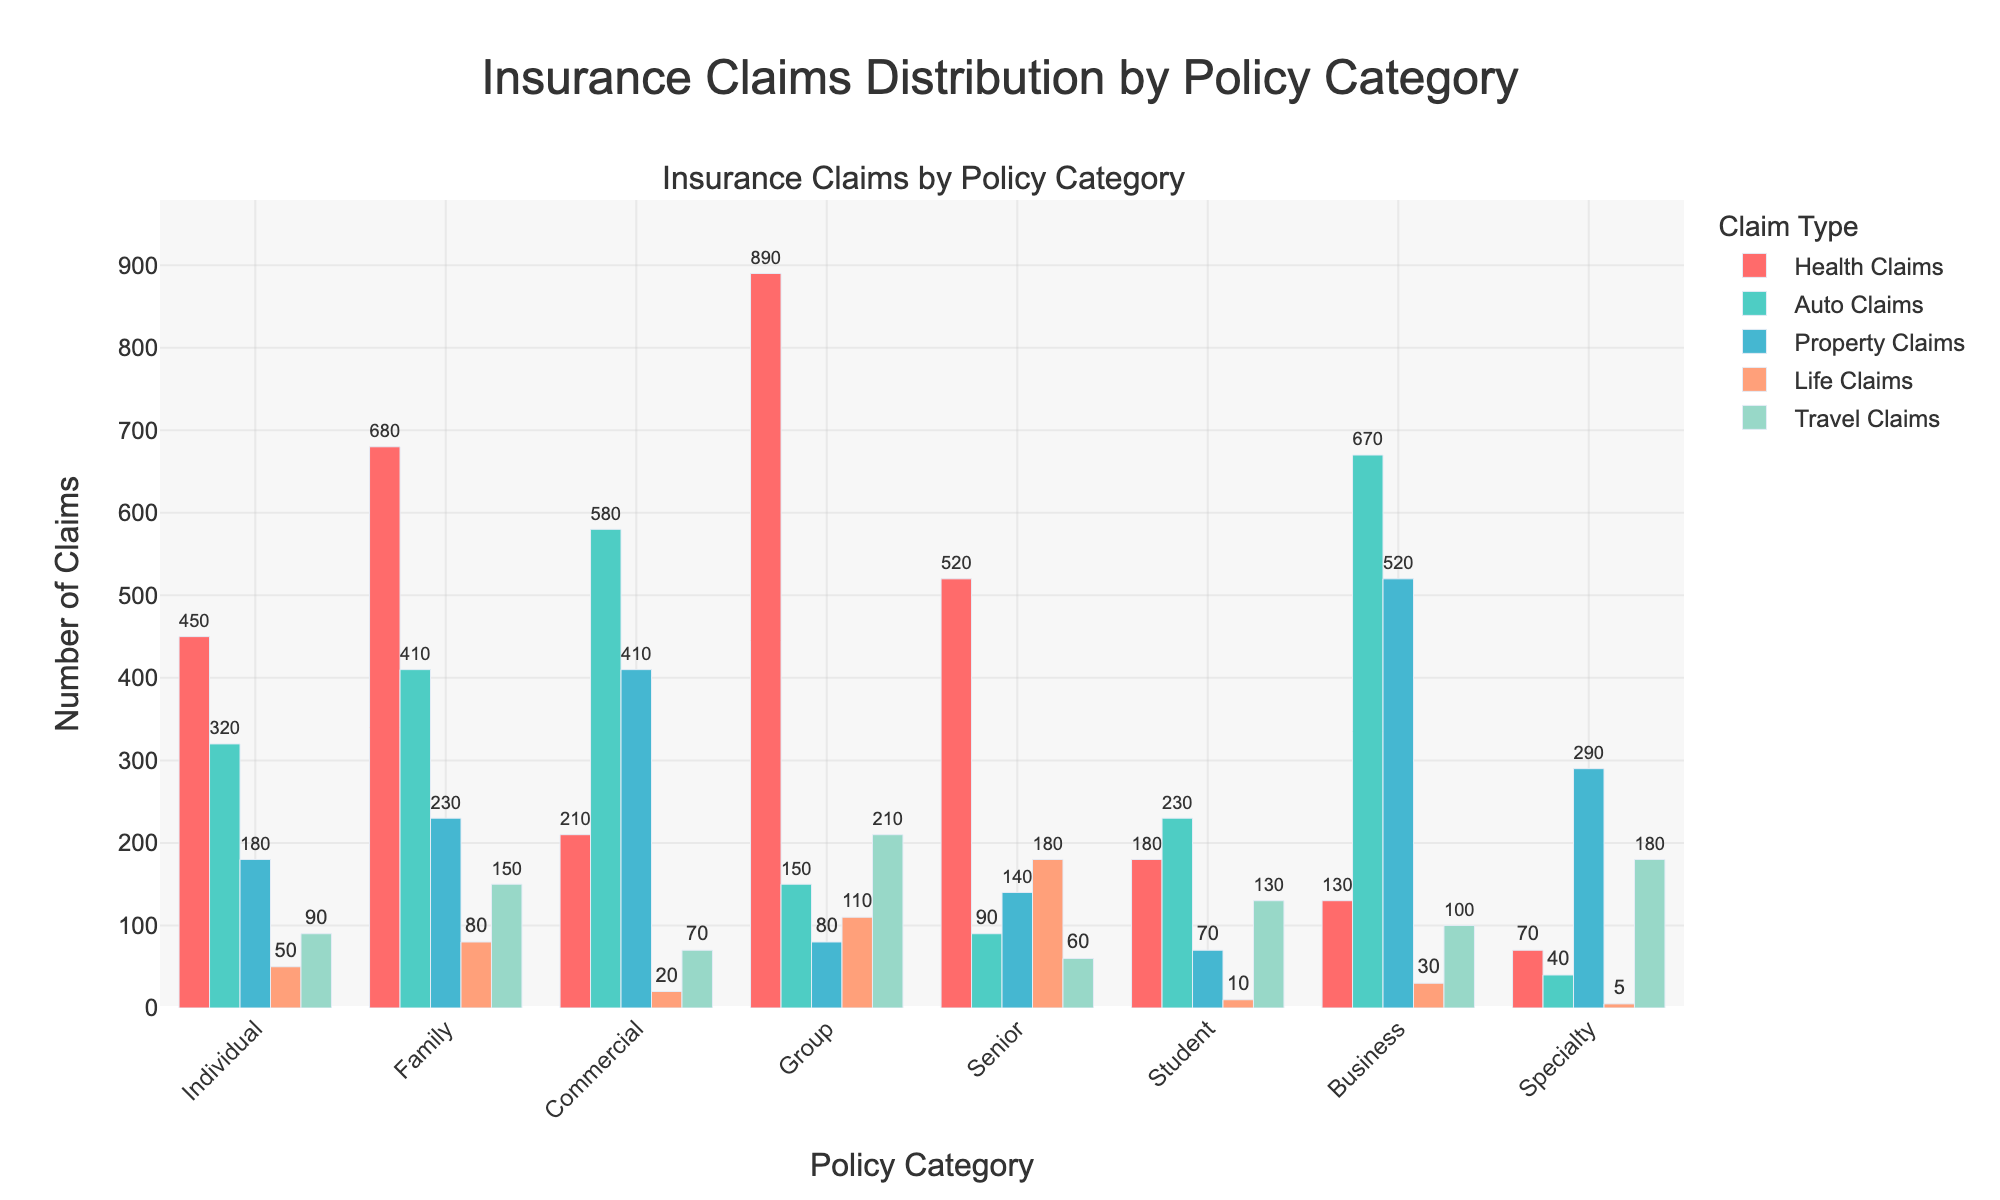What's the total number of Auto Claims across all policy categories? Add the number of Auto Claims for all policy categories: 320 + 410 + 580 + 150 + 90 + 230 + 670 + 40 = 2490
Answer: 2490 Which policy category has the highest number of Health Claims? Look at the bars for Health Claims and identify the tallest bar. The tallest bar corresponds to Group with 890 claims.
Answer: Group Are there more Property Claims in the Family category or the Commercial category? Compare the height of the bars for Property Claims in the Family (230) and Commercial (410) categories. Commercial has more.
Answer: Commercial What's the sum of Property Claims and Life Claims in the Senior category? Add the number of Property Claims and Life Claims in the Senior category: 140 + 180 = 320
Answer: 320 Which policy category has the least number of Travel Claims? Identify the category with the shortest bar in the Travel Claims section. The shortest bar corresponds to Specialty with 180 claims.
Answer: Specialty What's the difference between the number of Auto Claims and Health Claims in the Business category? Subtract the number of Health Claims from Auto Claims in the Business category: 670 - 130 = 540
Answer: 540 What's the average number of claims for Travel Claims across all categories? Add all the Travel Claims and divide by the number of categories: (90 + 150 + 70 + 210 + 60 + 130 + 100 + 180) / 8 = 123.75
Answer: 123.75 In the Individual category, how does the number of Life Claims compare to the number of Travel Claims? Compare the values for Life Claims (50) and Travel Claims (90) in the Individual category. Travel Claims are higher.
Answer: Travel Claims are higher How many more Auto Claims are there in the Commercial category compared to the Group category? Subtract the number of Auto Claims in the Group category from the number in the Commercial category: 580 - 150 = 430
Answer: 430 What are the three categories with the highest number of Life Claims, in descending order? Identify the three categories with the highest Life Claims: Group (110), Senior (180), Business (30). Ordered by number: Senior, Group, Business
Answer: Senior, Group, Business 